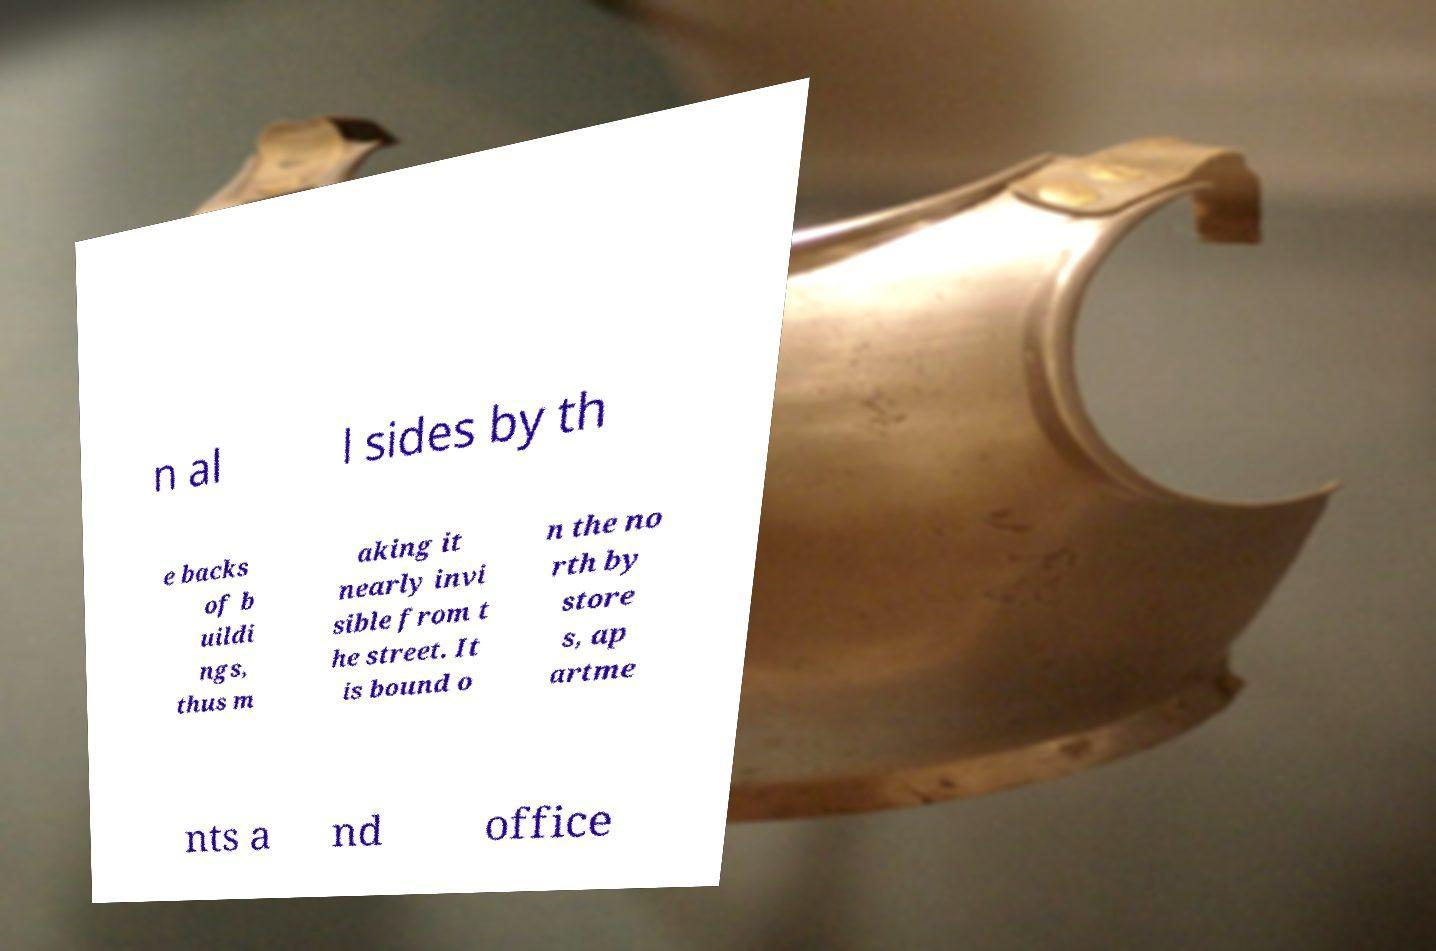I need the written content from this picture converted into text. Can you do that? n al l sides by th e backs of b uildi ngs, thus m aking it nearly invi sible from t he street. It is bound o n the no rth by store s, ap artme nts a nd office 